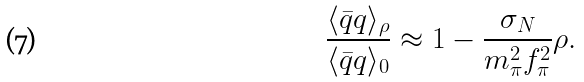<formula> <loc_0><loc_0><loc_500><loc_500>\frac { \langle \bar { q } q \rangle _ { \rho } } { \langle \bar { q } q \rangle _ { 0 } } \approx 1 - \frac { \sigma _ { N } } { m _ { \pi } ^ { 2 } f _ { \pi } ^ { 2 } } \rho .</formula> 